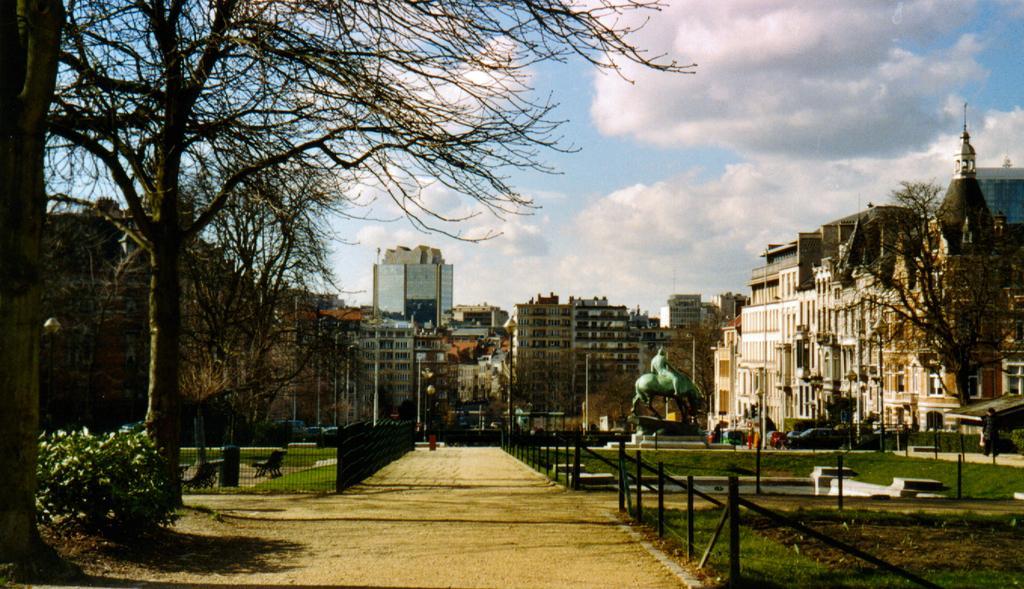Please provide a concise description of this image. In this image I can see buildings in the center of the image. Trees on the left and right sides of the image. At the top of the image I can see the sky. At the bottom of the image I can see a road and grills on both sides of the road. 